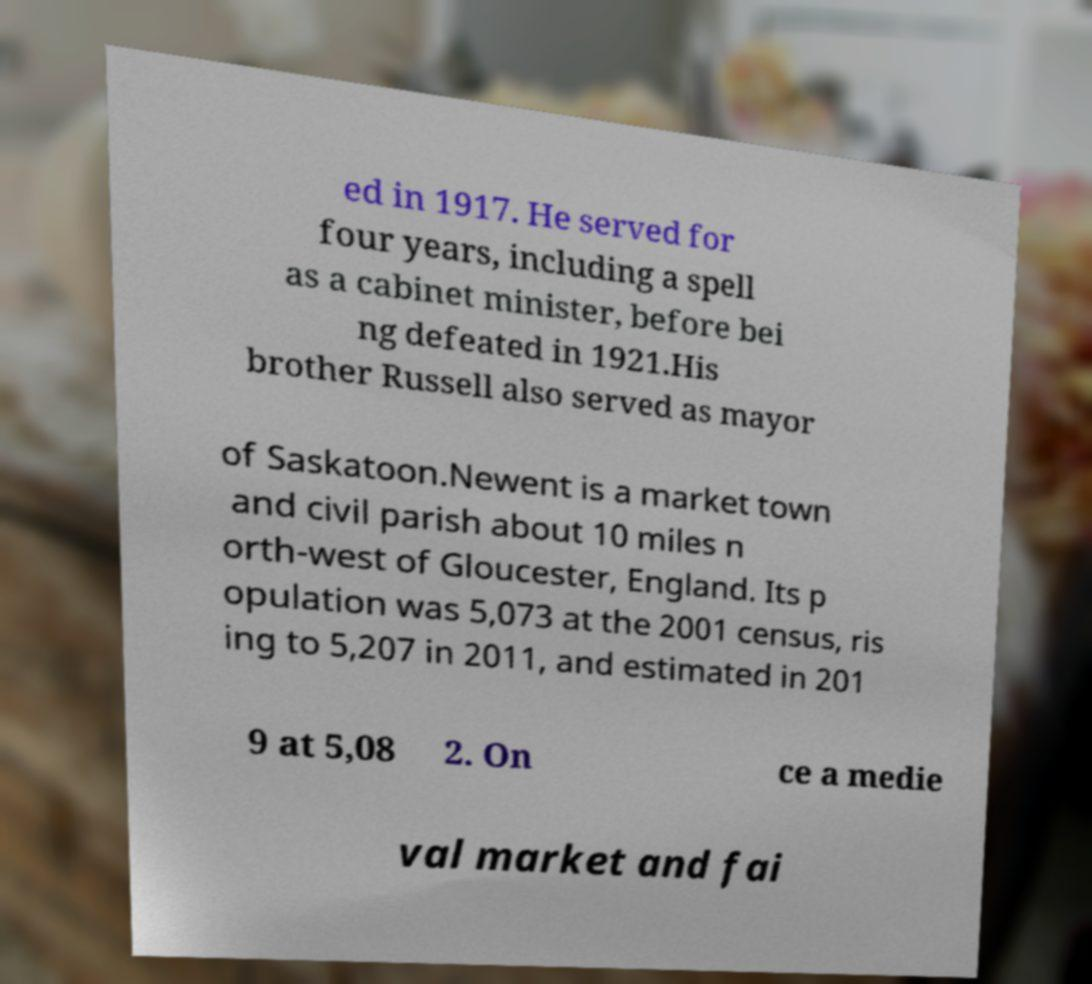What messages or text are displayed in this image? I need them in a readable, typed format. ed in 1917. He served for four years, including a spell as a cabinet minister, before bei ng defeated in 1921.His brother Russell also served as mayor of Saskatoon.Newent is a market town and civil parish about 10 miles n orth-west of Gloucester, England. Its p opulation was 5,073 at the 2001 census, ris ing to 5,207 in 2011, and estimated in 201 9 at 5,08 2. On ce a medie val market and fai 